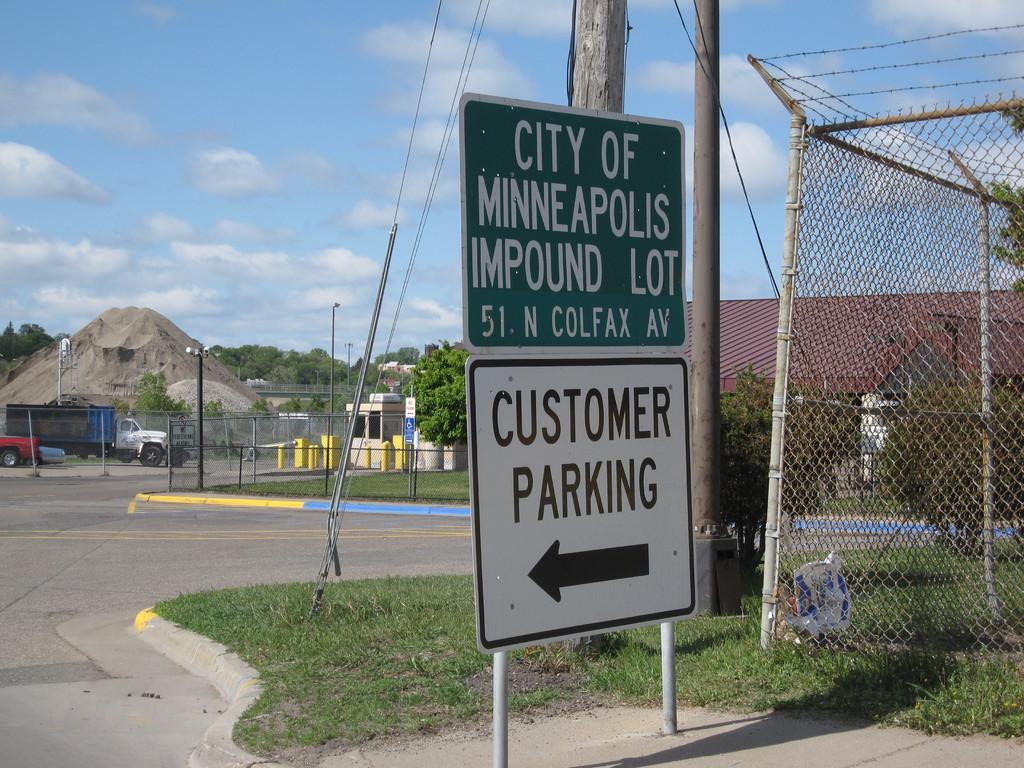What city is the impound lot in?
Make the answer very short. Minneapolis. What is to the left?
Keep it short and to the point. Customer parking. 